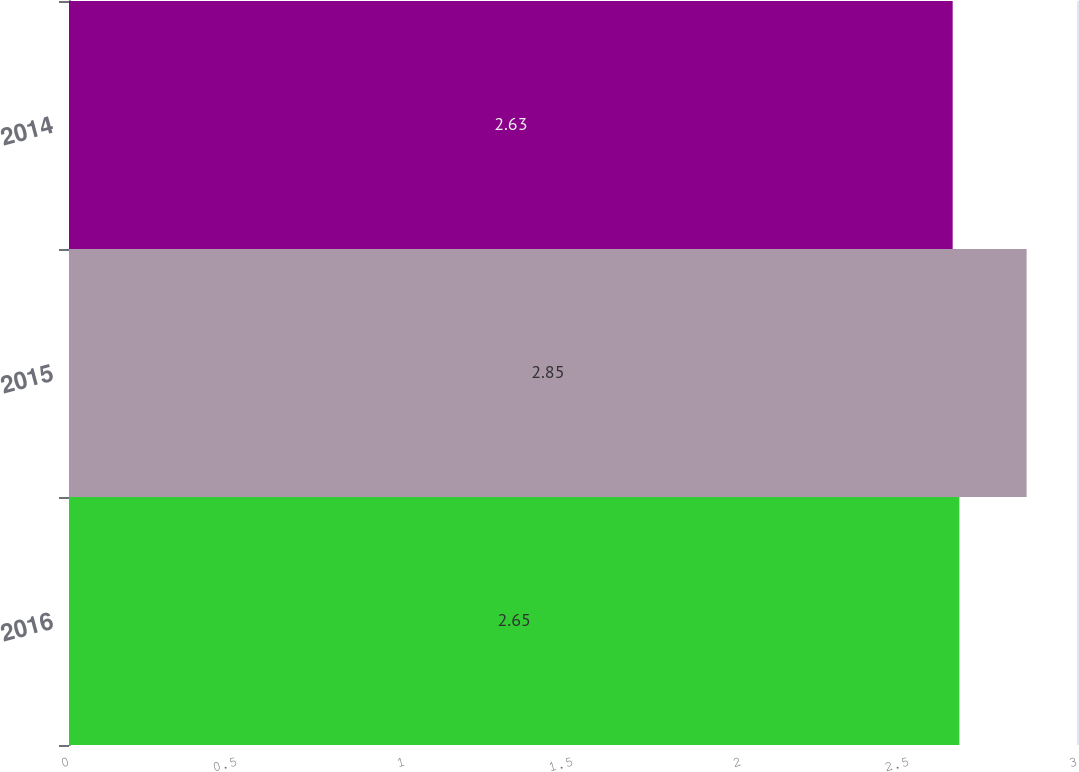Convert chart. <chart><loc_0><loc_0><loc_500><loc_500><bar_chart><fcel>2016<fcel>2015<fcel>2014<nl><fcel>2.65<fcel>2.85<fcel>2.63<nl></chart> 